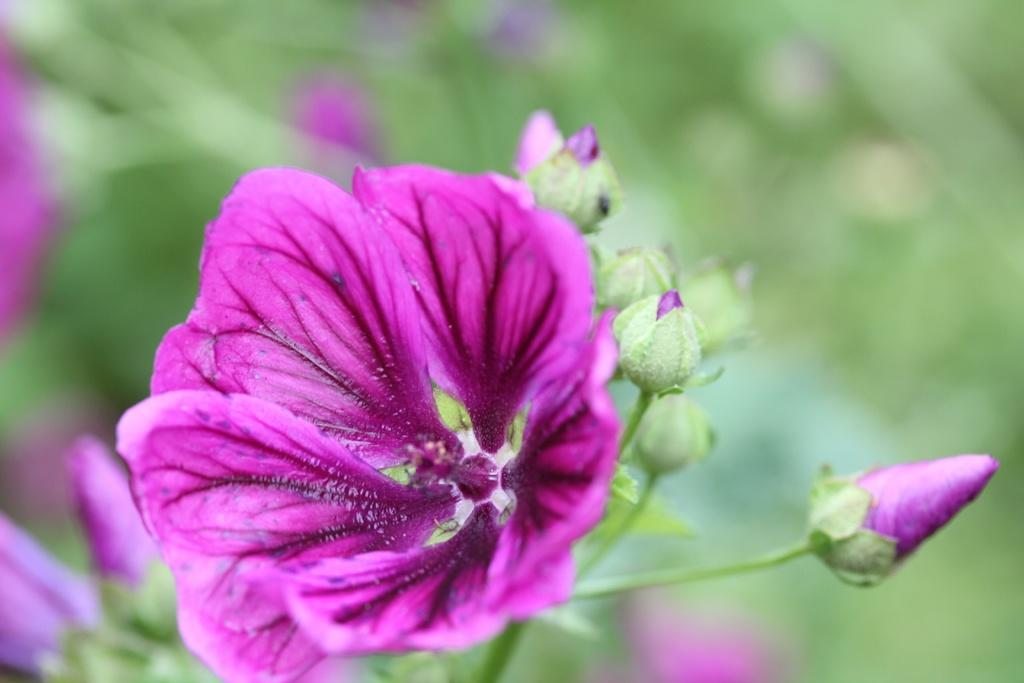What is the main subject of the image? The main subject of the image is flowers. Where are the flowers located in the image? The flowers are in the center of the image. What color are the flowers? The flowers are pink in color. What type of screw can be seen holding the calendar in the image? There is no screw or calendar present in the image; it only features pink flowers. 